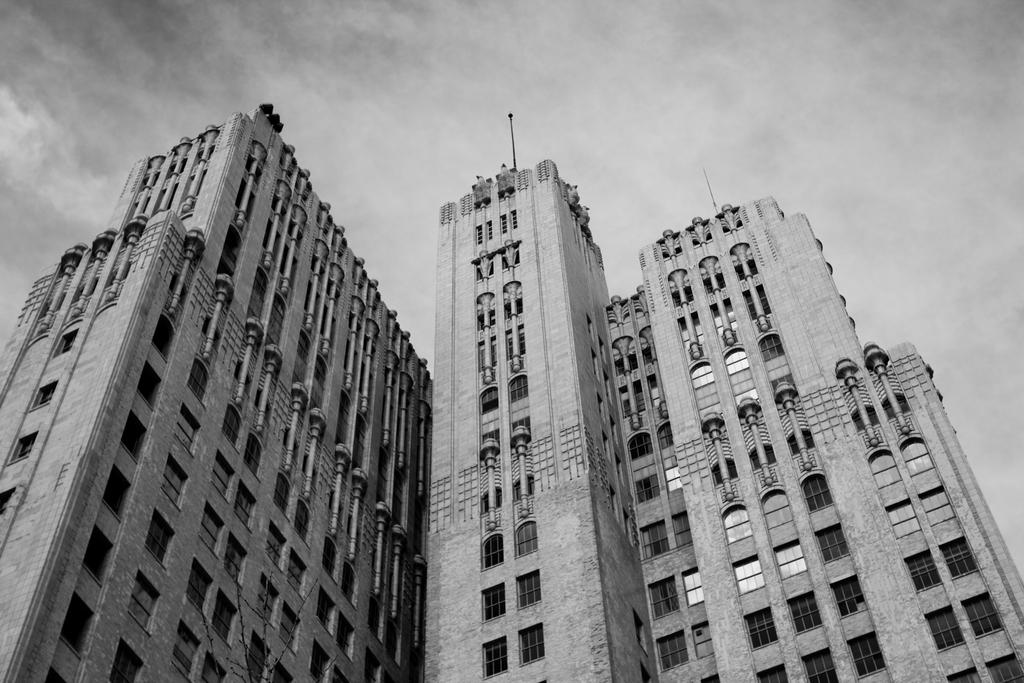What type of structures are visible in the image? There are buildings in the image. What is the condition of the sky in the image? The sky is cloudy at the top of the image. How do the giants affect the acoustics in the image? There are no giants present in the image, so their impact on the acoustics cannot be determined. 